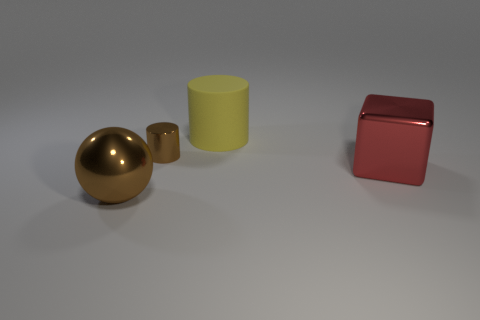What is the size of the metallic object that is both in front of the brown shiny cylinder and on the left side of the large red metallic cube?
Ensure brevity in your answer.  Large. What number of other objects are there of the same shape as the yellow rubber thing?
Offer a very short reply. 1. There is a tiny brown thing; is it the same shape as the large metal object that is behind the big brown object?
Offer a very short reply. No. There is a big red metallic block; what number of brown balls are in front of it?
Give a very brief answer. 1. Is there any other thing that is made of the same material as the big cylinder?
Offer a very short reply. No. Do the big object behind the small brown shiny cylinder and the tiny metallic object have the same shape?
Give a very brief answer. Yes. The big object that is to the right of the large yellow cylinder is what color?
Keep it short and to the point. Red. There is another brown thing that is the same material as the big brown thing; what shape is it?
Provide a succinct answer. Cylinder. Is there anything else of the same color as the large cube?
Give a very brief answer. No. Is the number of brown things behind the sphere greater than the number of tiny metal things to the right of the big rubber object?
Make the answer very short. Yes. 